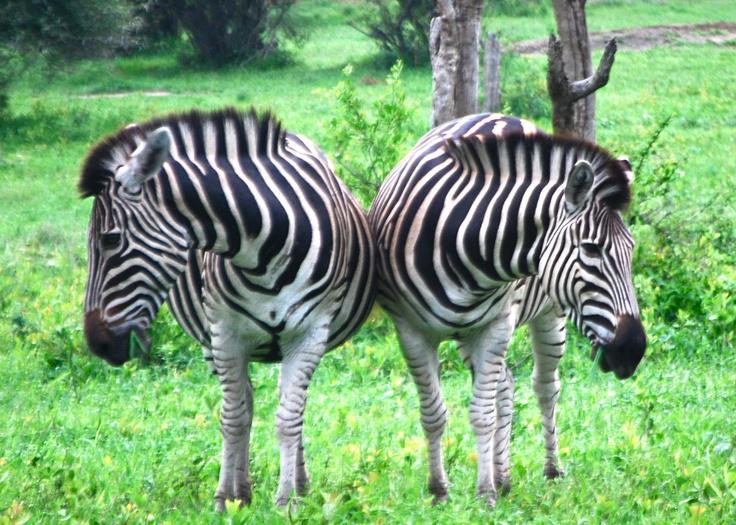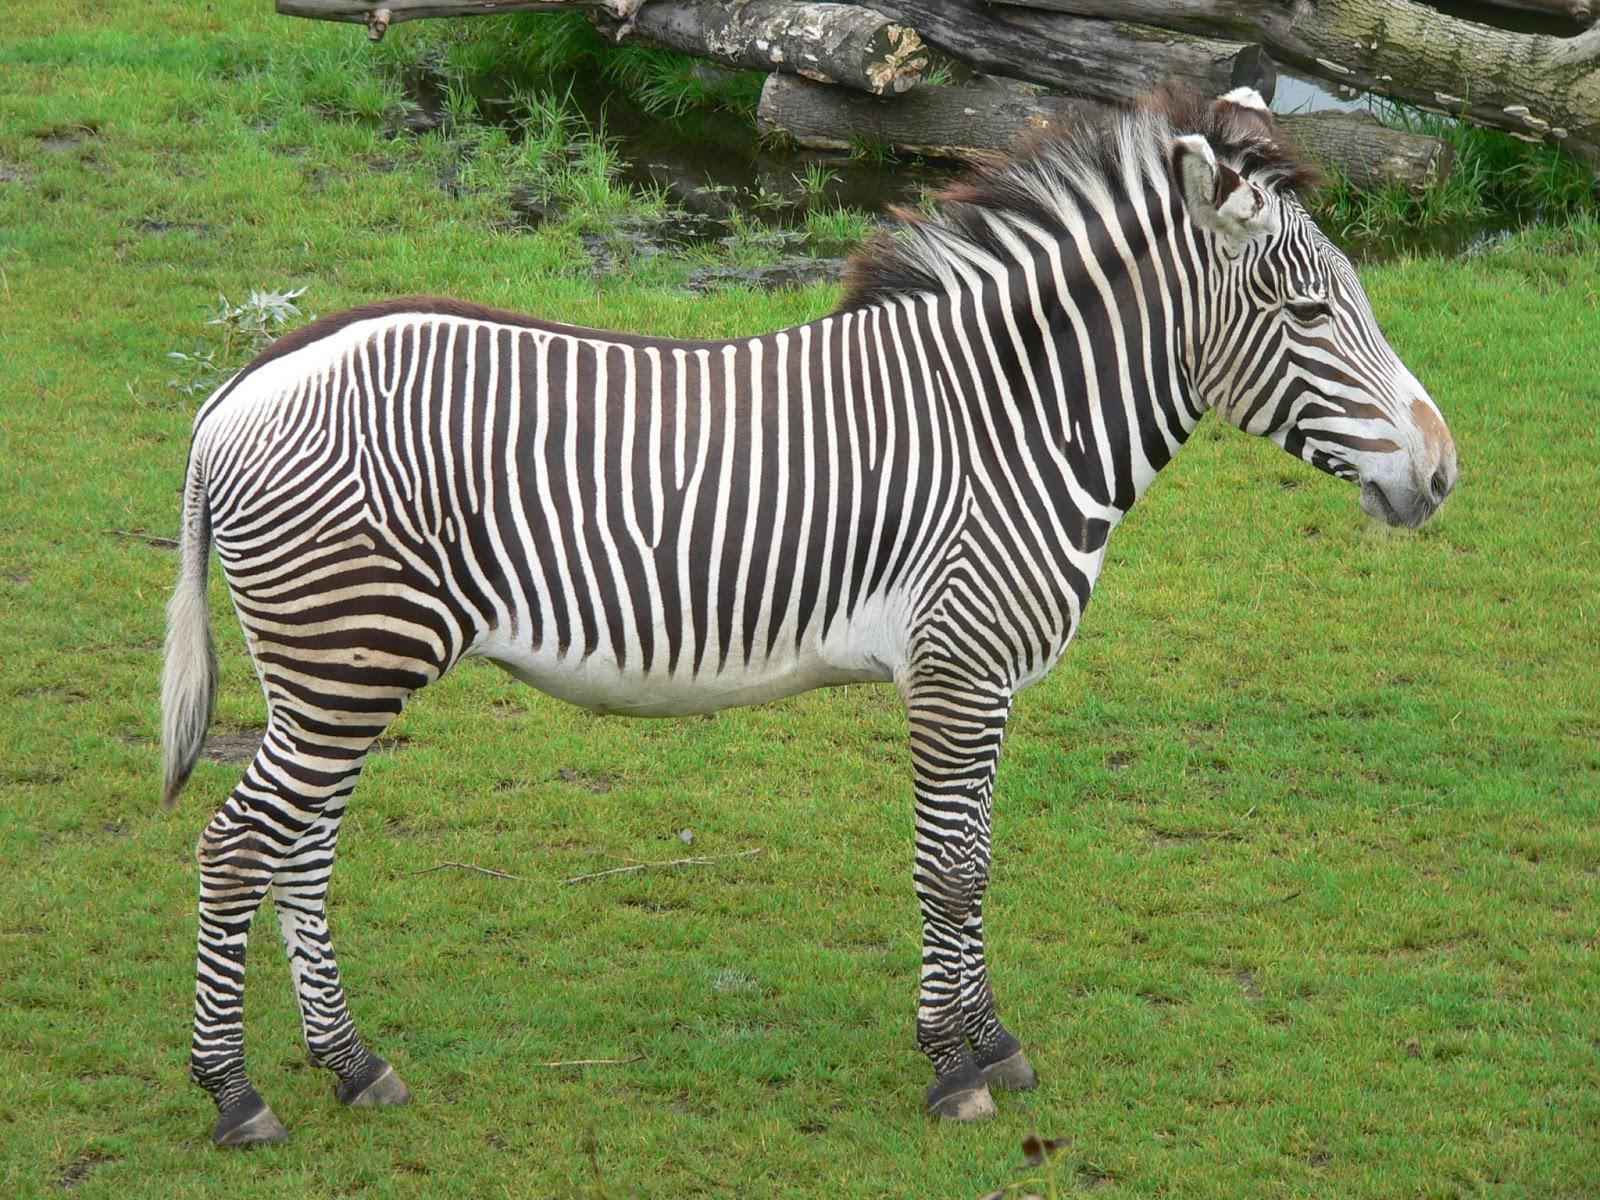The first image is the image on the left, the second image is the image on the right. Given the left and right images, does the statement "The left image shows exactly two zebras while the right image shows exactly one." hold true? Answer yes or no. Yes. The first image is the image on the left, the second image is the image on the right. For the images displayed, is the sentence "The images contain a total of three zebras." factually correct? Answer yes or no. Yes. 